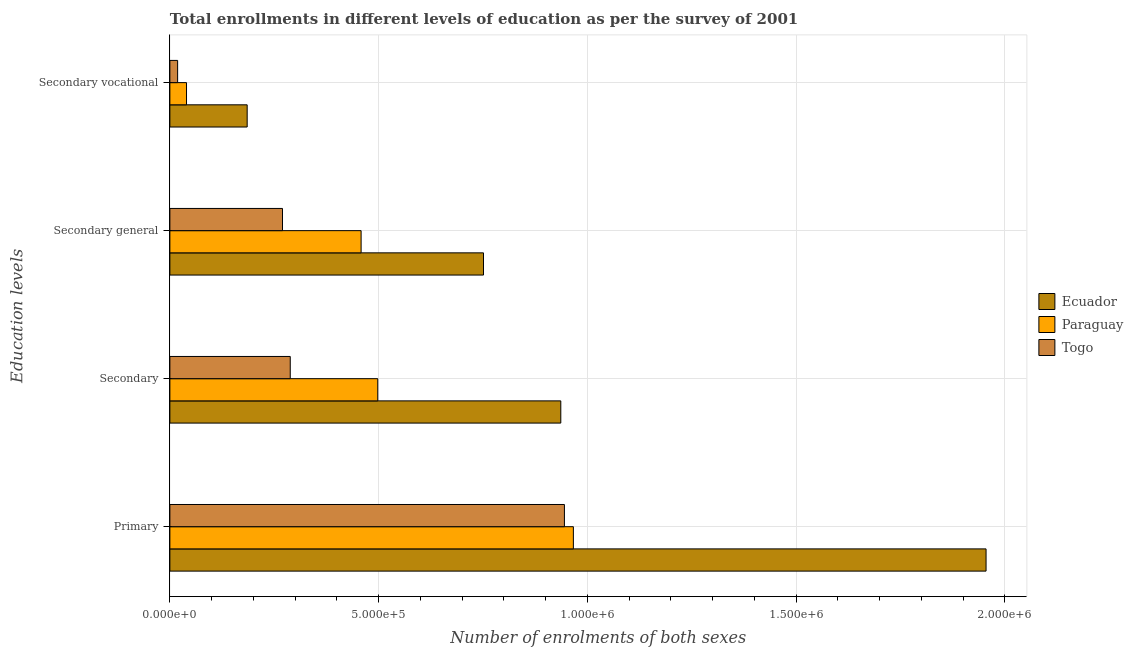How many different coloured bars are there?
Offer a very short reply. 3. Are the number of bars per tick equal to the number of legend labels?
Make the answer very short. Yes. How many bars are there on the 2nd tick from the bottom?
Your answer should be very brief. 3. What is the label of the 4th group of bars from the top?
Your response must be concise. Primary. What is the number of enrolments in secondary vocational education in Togo?
Make the answer very short. 1.86e+04. Across all countries, what is the maximum number of enrolments in secondary general education?
Provide a succinct answer. 7.51e+05. Across all countries, what is the minimum number of enrolments in secondary general education?
Offer a terse response. 2.70e+05. In which country was the number of enrolments in secondary vocational education maximum?
Keep it short and to the point. Ecuador. In which country was the number of enrolments in secondary vocational education minimum?
Keep it short and to the point. Togo. What is the total number of enrolments in secondary vocational education in the graph?
Offer a very short reply. 2.44e+05. What is the difference between the number of enrolments in secondary general education in Togo and that in Ecuador?
Offer a terse response. -4.81e+05. What is the difference between the number of enrolments in secondary general education in Togo and the number of enrolments in secondary education in Paraguay?
Make the answer very short. -2.28e+05. What is the average number of enrolments in secondary vocational education per country?
Your answer should be compact. 8.12e+04. What is the difference between the number of enrolments in secondary education and number of enrolments in primary education in Togo?
Provide a succinct answer. -6.57e+05. What is the ratio of the number of enrolments in secondary education in Ecuador to that in Paraguay?
Your answer should be compact. 1.88. Is the number of enrolments in secondary general education in Togo less than that in Ecuador?
Provide a short and direct response. Yes. What is the difference between the highest and the second highest number of enrolments in secondary general education?
Offer a very short reply. 2.93e+05. What is the difference between the highest and the lowest number of enrolments in primary education?
Offer a terse response. 1.01e+06. Is it the case that in every country, the sum of the number of enrolments in primary education and number of enrolments in secondary vocational education is greater than the sum of number of enrolments in secondary general education and number of enrolments in secondary education?
Your answer should be very brief. Yes. What does the 3rd bar from the top in Primary represents?
Your answer should be compact. Ecuador. What does the 3rd bar from the bottom in Primary represents?
Offer a very short reply. Togo. Are all the bars in the graph horizontal?
Give a very brief answer. Yes. What is the difference between two consecutive major ticks on the X-axis?
Make the answer very short. 5.00e+05. Does the graph contain any zero values?
Offer a very short reply. No. Does the graph contain grids?
Give a very brief answer. Yes. How many legend labels are there?
Your response must be concise. 3. How are the legend labels stacked?
Provide a short and direct response. Vertical. What is the title of the graph?
Provide a short and direct response. Total enrollments in different levels of education as per the survey of 2001. What is the label or title of the X-axis?
Offer a terse response. Number of enrolments of both sexes. What is the label or title of the Y-axis?
Your response must be concise. Education levels. What is the Number of enrolments of both sexes in Ecuador in Primary?
Give a very brief answer. 1.96e+06. What is the Number of enrolments of both sexes in Paraguay in Primary?
Offer a very short reply. 9.67e+05. What is the Number of enrolments of both sexes in Togo in Primary?
Make the answer very short. 9.45e+05. What is the Number of enrolments of both sexes in Ecuador in Secondary?
Ensure brevity in your answer.  9.36e+05. What is the Number of enrolments of both sexes of Paraguay in Secondary?
Your response must be concise. 4.98e+05. What is the Number of enrolments of both sexes in Togo in Secondary?
Provide a succinct answer. 2.88e+05. What is the Number of enrolments of both sexes of Ecuador in Secondary general?
Provide a succinct answer. 7.51e+05. What is the Number of enrolments of both sexes in Paraguay in Secondary general?
Provide a short and direct response. 4.58e+05. What is the Number of enrolments of both sexes in Togo in Secondary general?
Ensure brevity in your answer.  2.70e+05. What is the Number of enrolments of both sexes in Ecuador in Secondary vocational?
Your response must be concise. 1.85e+05. What is the Number of enrolments of both sexes of Paraguay in Secondary vocational?
Make the answer very short. 3.99e+04. What is the Number of enrolments of both sexes of Togo in Secondary vocational?
Your response must be concise. 1.86e+04. Across all Education levels, what is the maximum Number of enrolments of both sexes of Ecuador?
Keep it short and to the point. 1.96e+06. Across all Education levels, what is the maximum Number of enrolments of both sexes of Paraguay?
Offer a terse response. 9.67e+05. Across all Education levels, what is the maximum Number of enrolments of both sexes in Togo?
Your answer should be very brief. 9.45e+05. Across all Education levels, what is the minimum Number of enrolments of both sexes of Ecuador?
Your response must be concise. 1.85e+05. Across all Education levels, what is the minimum Number of enrolments of both sexes in Paraguay?
Ensure brevity in your answer.  3.99e+04. Across all Education levels, what is the minimum Number of enrolments of both sexes in Togo?
Provide a succinct answer. 1.86e+04. What is the total Number of enrolments of both sexes in Ecuador in the graph?
Ensure brevity in your answer.  3.83e+06. What is the total Number of enrolments of both sexes in Paraguay in the graph?
Your answer should be compact. 1.96e+06. What is the total Number of enrolments of both sexes in Togo in the graph?
Your response must be concise. 1.52e+06. What is the difference between the Number of enrolments of both sexes in Ecuador in Primary and that in Secondary?
Keep it short and to the point. 1.02e+06. What is the difference between the Number of enrolments of both sexes of Paraguay in Primary and that in Secondary?
Offer a very short reply. 4.69e+05. What is the difference between the Number of enrolments of both sexes of Togo in Primary and that in Secondary?
Keep it short and to the point. 6.57e+05. What is the difference between the Number of enrolments of both sexes in Ecuador in Primary and that in Secondary general?
Make the answer very short. 1.20e+06. What is the difference between the Number of enrolments of both sexes in Paraguay in Primary and that in Secondary general?
Provide a succinct answer. 5.08e+05. What is the difference between the Number of enrolments of both sexes of Togo in Primary and that in Secondary general?
Ensure brevity in your answer.  6.75e+05. What is the difference between the Number of enrolments of both sexes in Ecuador in Primary and that in Secondary vocational?
Provide a succinct answer. 1.77e+06. What is the difference between the Number of enrolments of both sexes in Paraguay in Primary and that in Secondary vocational?
Keep it short and to the point. 9.27e+05. What is the difference between the Number of enrolments of both sexes of Togo in Primary and that in Secondary vocational?
Provide a succinct answer. 9.27e+05. What is the difference between the Number of enrolments of both sexes of Ecuador in Secondary and that in Secondary general?
Make the answer very short. 1.85e+05. What is the difference between the Number of enrolments of both sexes in Paraguay in Secondary and that in Secondary general?
Give a very brief answer. 3.99e+04. What is the difference between the Number of enrolments of both sexes of Togo in Secondary and that in Secondary general?
Make the answer very short. 1.86e+04. What is the difference between the Number of enrolments of both sexes in Ecuador in Secondary and that in Secondary vocational?
Offer a very short reply. 7.51e+05. What is the difference between the Number of enrolments of both sexes of Paraguay in Secondary and that in Secondary vocational?
Your response must be concise. 4.58e+05. What is the difference between the Number of enrolments of both sexes in Togo in Secondary and that in Secondary vocational?
Provide a short and direct response. 2.70e+05. What is the difference between the Number of enrolments of both sexes of Ecuador in Secondary general and that in Secondary vocational?
Your answer should be compact. 5.66e+05. What is the difference between the Number of enrolments of both sexes in Paraguay in Secondary general and that in Secondary vocational?
Offer a very short reply. 4.18e+05. What is the difference between the Number of enrolments of both sexes in Togo in Secondary general and that in Secondary vocational?
Your response must be concise. 2.51e+05. What is the difference between the Number of enrolments of both sexes of Ecuador in Primary and the Number of enrolments of both sexes of Paraguay in Secondary?
Make the answer very short. 1.46e+06. What is the difference between the Number of enrolments of both sexes of Ecuador in Primary and the Number of enrolments of both sexes of Togo in Secondary?
Offer a very short reply. 1.67e+06. What is the difference between the Number of enrolments of both sexes of Paraguay in Primary and the Number of enrolments of both sexes of Togo in Secondary?
Your response must be concise. 6.78e+05. What is the difference between the Number of enrolments of both sexes of Ecuador in Primary and the Number of enrolments of both sexes of Paraguay in Secondary general?
Your response must be concise. 1.50e+06. What is the difference between the Number of enrolments of both sexes of Ecuador in Primary and the Number of enrolments of both sexes of Togo in Secondary general?
Give a very brief answer. 1.69e+06. What is the difference between the Number of enrolments of both sexes of Paraguay in Primary and the Number of enrolments of both sexes of Togo in Secondary general?
Your answer should be compact. 6.97e+05. What is the difference between the Number of enrolments of both sexes of Ecuador in Primary and the Number of enrolments of both sexes of Paraguay in Secondary vocational?
Make the answer very short. 1.92e+06. What is the difference between the Number of enrolments of both sexes of Ecuador in Primary and the Number of enrolments of both sexes of Togo in Secondary vocational?
Provide a succinct answer. 1.94e+06. What is the difference between the Number of enrolments of both sexes in Paraguay in Primary and the Number of enrolments of both sexes in Togo in Secondary vocational?
Provide a succinct answer. 9.48e+05. What is the difference between the Number of enrolments of both sexes of Ecuador in Secondary and the Number of enrolments of both sexes of Paraguay in Secondary general?
Offer a very short reply. 4.78e+05. What is the difference between the Number of enrolments of both sexes of Ecuador in Secondary and the Number of enrolments of both sexes of Togo in Secondary general?
Make the answer very short. 6.67e+05. What is the difference between the Number of enrolments of both sexes of Paraguay in Secondary and the Number of enrolments of both sexes of Togo in Secondary general?
Keep it short and to the point. 2.28e+05. What is the difference between the Number of enrolments of both sexes in Ecuador in Secondary and the Number of enrolments of both sexes in Paraguay in Secondary vocational?
Your answer should be very brief. 8.97e+05. What is the difference between the Number of enrolments of both sexes of Ecuador in Secondary and the Number of enrolments of both sexes of Togo in Secondary vocational?
Keep it short and to the point. 9.18e+05. What is the difference between the Number of enrolments of both sexes in Paraguay in Secondary and the Number of enrolments of both sexes in Togo in Secondary vocational?
Your response must be concise. 4.79e+05. What is the difference between the Number of enrolments of both sexes in Ecuador in Secondary general and the Number of enrolments of both sexes in Paraguay in Secondary vocational?
Give a very brief answer. 7.11e+05. What is the difference between the Number of enrolments of both sexes of Ecuador in Secondary general and the Number of enrolments of both sexes of Togo in Secondary vocational?
Your answer should be very brief. 7.33e+05. What is the difference between the Number of enrolments of both sexes of Paraguay in Secondary general and the Number of enrolments of both sexes of Togo in Secondary vocational?
Your answer should be compact. 4.40e+05. What is the average Number of enrolments of both sexes in Ecuador per Education levels?
Provide a short and direct response. 9.57e+05. What is the average Number of enrolments of both sexes of Paraguay per Education levels?
Your answer should be compact. 4.91e+05. What is the average Number of enrolments of both sexes of Togo per Education levels?
Offer a very short reply. 3.80e+05. What is the difference between the Number of enrolments of both sexes in Ecuador and Number of enrolments of both sexes in Paraguay in Primary?
Your answer should be very brief. 9.89e+05. What is the difference between the Number of enrolments of both sexes of Ecuador and Number of enrolments of both sexes of Togo in Primary?
Ensure brevity in your answer.  1.01e+06. What is the difference between the Number of enrolments of both sexes of Paraguay and Number of enrolments of both sexes of Togo in Primary?
Your answer should be compact. 2.14e+04. What is the difference between the Number of enrolments of both sexes of Ecuador and Number of enrolments of both sexes of Paraguay in Secondary?
Offer a terse response. 4.38e+05. What is the difference between the Number of enrolments of both sexes of Ecuador and Number of enrolments of both sexes of Togo in Secondary?
Your answer should be compact. 6.48e+05. What is the difference between the Number of enrolments of both sexes in Paraguay and Number of enrolments of both sexes in Togo in Secondary?
Your response must be concise. 2.10e+05. What is the difference between the Number of enrolments of both sexes in Ecuador and Number of enrolments of both sexes in Paraguay in Secondary general?
Give a very brief answer. 2.93e+05. What is the difference between the Number of enrolments of both sexes of Ecuador and Number of enrolments of both sexes of Togo in Secondary general?
Offer a very short reply. 4.81e+05. What is the difference between the Number of enrolments of both sexes of Paraguay and Number of enrolments of both sexes of Togo in Secondary general?
Provide a short and direct response. 1.88e+05. What is the difference between the Number of enrolments of both sexes in Ecuador and Number of enrolments of both sexes in Paraguay in Secondary vocational?
Your answer should be compact. 1.45e+05. What is the difference between the Number of enrolments of both sexes of Ecuador and Number of enrolments of both sexes of Togo in Secondary vocational?
Ensure brevity in your answer.  1.67e+05. What is the difference between the Number of enrolments of both sexes in Paraguay and Number of enrolments of both sexes in Togo in Secondary vocational?
Your answer should be very brief. 2.13e+04. What is the ratio of the Number of enrolments of both sexes in Ecuador in Primary to that in Secondary?
Give a very brief answer. 2.09. What is the ratio of the Number of enrolments of both sexes of Paraguay in Primary to that in Secondary?
Offer a terse response. 1.94. What is the ratio of the Number of enrolments of both sexes in Togo in Primary to that in Secondary?
Keep it short and to the point. 3.28. What is the ratio of the Number of enrolments of both sexes in Ecuador in Primary to that in Secondary general?
Your response must be concise. 2.6. What is the ratio of the Number of enrolments of both sexes in Paraguay in Primary to that in Secondary general?
Keep it short and to the point. 2.11. What is the ratio of the Number of enrolments of both sexes in Togo in Primary to that in Secondary general?
Your answer should be very brief. 3.5. What is the ratio of the Number of enrolments of both sexes in Ecuador in Primary to that in Secondary vocational?
Your response must be concise. 10.56. What is the ratio of the Number of enrolments of both sexes in Paraguay in Primary to that in Secondary vocational?
Keep it short and to the point. 24.25. What is the ratio of the Number of enrolments of both sexes of Togo in Primary to that in Secondary vocational?
Keep it short and to the point. 50.89. What is the ratio of the Number of enrolments of both sexes in Ecuador in Secondary to that in Secondary general?
Provide a succinct answer. 1.25. What is the ratio of the Number of enrolments of both sexes of Paraguay in Secondary to that in Secondary general?
Offer a terse response. 1.09. What is the ratio of the Number of enrolments of both sexes in Togo in Secondary to that in Secondary general?
Provide a short and direct response. 1.07. What is the ratio of the Number of enrolments of both sexes of Ecuador in Secondary to that in Secondary vocational?
Your response must be concise. 5.06. What is the ratio of the Number of enrolments of both sexes of Paraguay in Secondary to that in Secondary vocational?
Offer a terse response. 12.49. What is the ratio of the Number of enrolments of both sexes of Togo in Secondary to that in Secondary vocational?
Offer a terse response. 15.53. What is the ratio of the Number of enrolments of both sexes in Ecuador in Secondary general to that in Secondary vocational?
Offer a very short reply. 4.06. What is the ratio of the Number of enrolments of both sexes in Paraguay in Secondary general to that in Secondary vocational?
Make the answer very short. 11.49. What is the ratio of the Number of enrolments of both sexes in Togo in Secondary general to that in Secondary vocational?
Your answer should be compact. 14.53. What is the difference between the highest and the second highest Number of enrolments of both sexes in Ecuador?
Provide a succinct answer. 1.02e+06. What is the difference between the highest and the second highest Number of enrolments of both sexes of Paraguay?
Give a very brief answer. 4.69e+05. What is the difference between the highest and the second highest Number of enrolments of both sexes in Togo?
Your answer should be compact. 6.57e+05. What is the difference between the highest and the lowest Number of enrolments of both sexes of Ecuador?
Offer a terse response. 1.77e+06. What is the difference between the highest and the lowest Number of enrolments of both sexes in Paraguay?
Your answer should be very brief. 9.27e+05. What is the difference between the highest and the lowest Number of enrolments of both sexes of Togo?
Ensure brevity in your answer.  9.27e+05. 